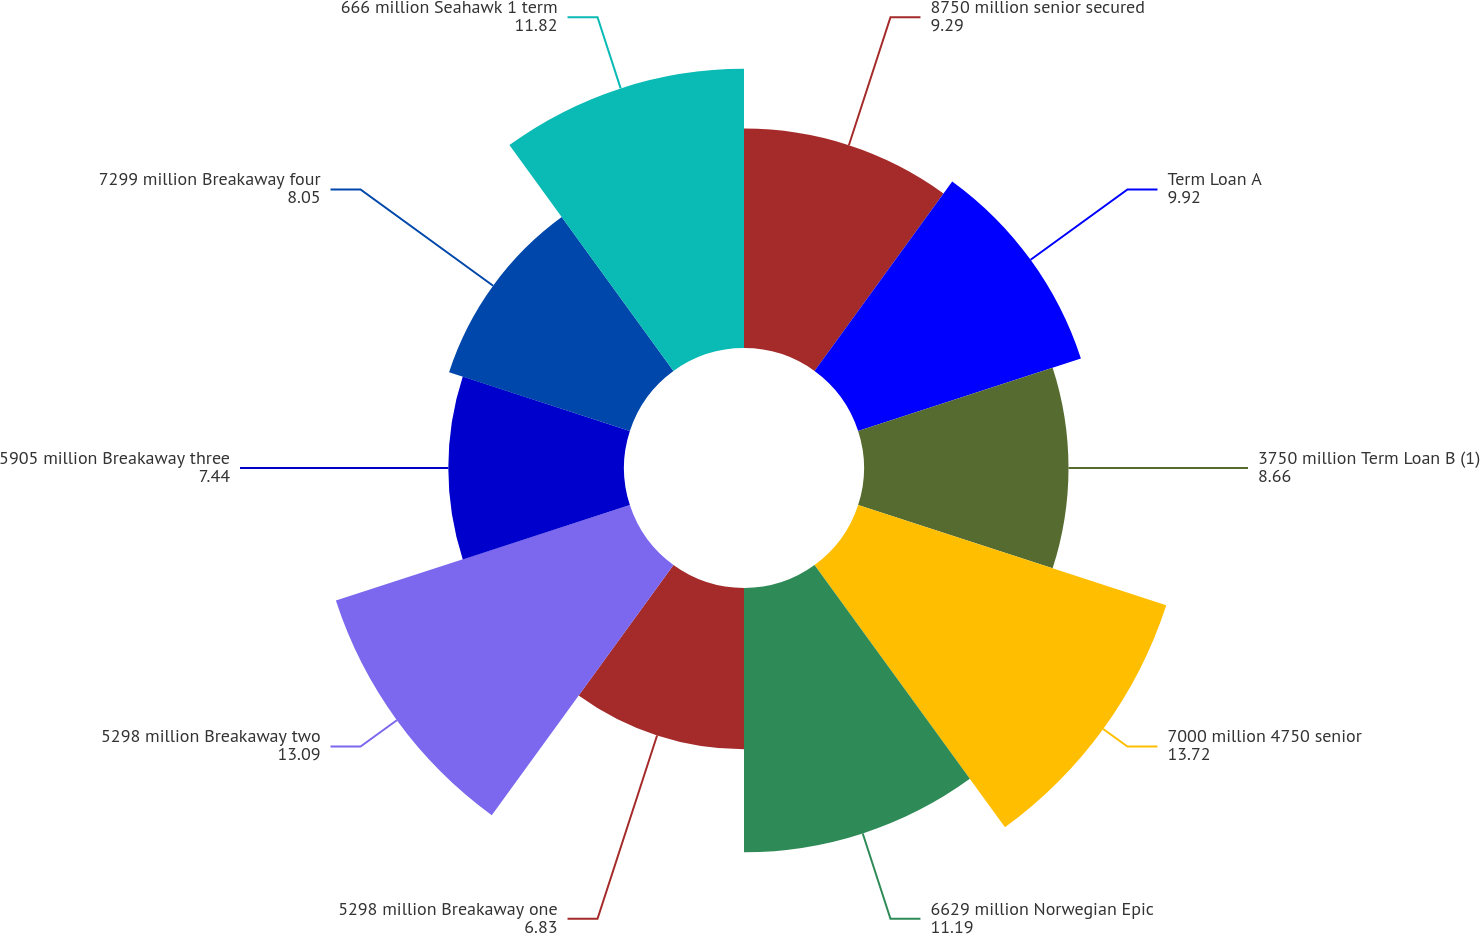Convert chart. <chart><loc_0><loc_0><loc_500><loc_500><pie_chart><fcel>8750 million senior secured<fcel>Term Loan A<fcel>3750 million Term Loan B (1)<fcel>7000 million 4750 senior<fcel>6629 million Norwegian Epic<fcel>5298 million Breakaway one<fcel>5298 million Breakaway two<fcel>5905 million Breakaway three<fcel>7299 million Breakaway four<fcel>666 million Seahawk 1 term<nl><fcel>9.29%<fcel>9.92%<fcel>8.66%<fcel>13.72%<fcel>11.19%<fcel>6.83%<fcel>13.09%<fcel>7.44%<fcel>8.05%<fcel>11.82%<nl></chart> 